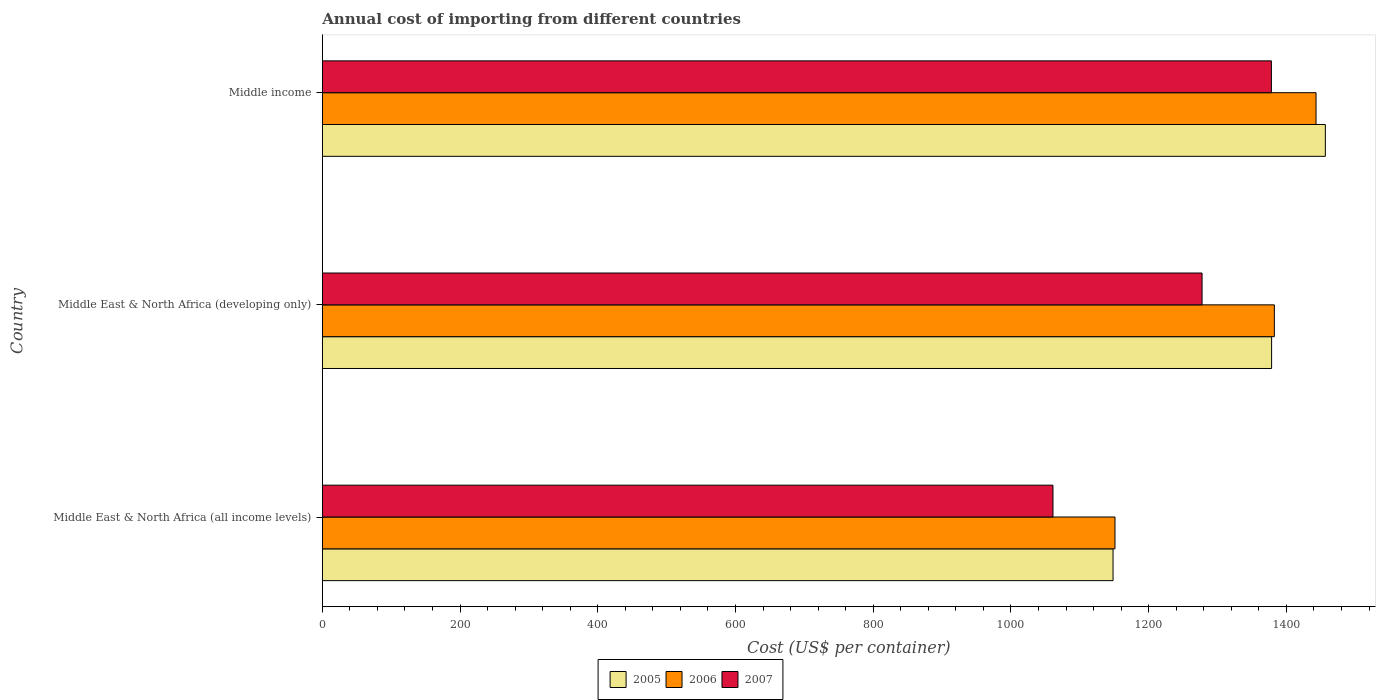How many different coloured bars are there?
Make the answer very short. 3. Are the number of bars per tick equal to the number of legend labels?
Offer a very short reply. Yes. How many bars are there on the 2nd tick from the bottom?
Give a very brief answer. 3. What is the label of the 2nd group of bars from the top?
Offer a terse response. Middle East & North Africa (developing only). In how many cases, is the number of bars for a given country not equal to the number of legend labels?
Offer a very short reply. 0. What is the total annual cost of importing in 2007 in Middle East & North Africa (all income levels)?
Ensure brevity in your answer.  1061. Across all countries, what is the maximum total annual cost of importing in 2007?
Provide a short and direct response. 1378.2. Across all countries, what is the minimum total annual cost of importing in 2005?
Your answer should be compact. 1148.24. In which country was the total annual cost of importing in 2006 minimum?
Give a very brief answer. Middle East & North Africa (all income levels). What is the total total annual cost of importing in 2005 in the graph?
Provide a succinct answer. 3983.27. What is the difference between the total annual cost of importing in 2006 in Middle East & North Africa (all income levels) and that in Middle East & North Africa (developing only)?
Ensure brevity in your answer.  -231.44. What is the difference between the total annual cost of importing in 2007 in Middle East & North Africa (developing only) and the total annual cost of importing in 2005 in Middle East & North Africa (all income levels)?
Your answer should be compact. 129.26. What is the average total annual cost of importing in 2005 per country?
Ensure brevity in your answer.  1327.76. What is the difference between the total annual cost of importing in 2006 and total annual cost of importing in 2005 in Middle East & North Africa (all income levels)?
Give a very brief answer. 2.82. In how many countries, is the total annual cost of importing in 2005 greater than 1320 US$?
Give a very brief answer. 2. What is the ratio of the total annual cost of importing in 2006 in Middle East & North Africa (all income levels) to that in Middle East & North Africa (developing only)?
Keep it short and to the point. 0.83. What is the difference between the highest and the second highest total annual cost of importing in 2006?
Provide a short and direct response. 60.51. What is the difference between the highest and the lowest total annual cost of importing in 2005?
Give a very brief answer. 308.3. In how many countries, is the total annual cost of importing in 2006 greater than the average total annual cost of importing in 2006 taken over all countries?
Your response must be concise. 2. What does the 3rd bar from the bottom in Middle income represents?
Make the answer very short. 2007. Is it the case that in every country, the sum of the total annual cost of importing in 2005 and total annual cost of importing in 2006 is greater than the total annual cost of importing in 2007?
Provide a short and direct response. Yes. Are all the bars in the graph horizontal?
Ensure brevity in your answer.  Yes. What is the difference between two consecutive major ticks on the X-axis?
Keep it short and to the point. 200. Are the values on the major ticks of X-axis written in scientific E-notation?
Your answer should be very brief. No. Does the graph contain grids?
Give a very brief answer. No. Where does the legend appear in the graph?
Provide a short and direct response. Bottom center. How many legend labels are there?
Your answer should be very brief. 3. How are the legend labels stacked?
Provide a succinct answer. Horizontal. What is the title of the graph?
Your answer should be compact. Annual cost of importing from different countries. What is the label or title of the X-axis?
Keep it short and to the point. Cost (US$ per container). What is the label or title of the Y-axis?
Provide a short and direct response. Country. What is the Cost (US$ per container) of 2005 in Middle East & North Africa (all income levels)?
Ensure brevity in your answer.  1148.24. What is the Cost (US$ per container) in 2006 in Middle East & North Africa (all income levels)?
Offer a very short reply. 1151.06. What is the Cost (US$ per container) of 2007 in Middle East & North Africa (all income levels)?
Offer a terse response. 1061. What is the Cost (US$ per container) of 2005 in Middle East & North Africa (developing only)?
Provide a short and direct response. 1378.5. What is the Cost (US$ per container) of 2006 in Middle East & North Africa (developing only)?
Your response must be concise. 1382.5. What is the Cost (US$ per container) in 2007 in Middle East & North Africa (developing only)?
Give a very brief answer. 1277.5. What is the Cost (US$ per container) in 2005 in Middle income?
Make the answer very short. 1456.53. What is the Cost (US$ per container) of 2006 in Middle income?
Keep it short and to the point. 1443.01. What is the Cost (US$ per container) in 2007 in Middle income?
Provide a short and direct response. 1378.2. Across all countries, what is the maximum Cost (US$ per container) in 2005?
Your answer should be very brief. 1456.53. Across all countries, what is the maximum Cost (US$ per container) in 2006?
Your answer should be very brief. 1443.01. Across all countries, what is the maximum Cost (US$ per container) of 2007?
Provide a short and direct response. 1378.2. Across all countries, what is the minimum Cost (US$ per container) of 2005?
Provide a succinct answer. 1148.24. Across all countries, what is the minimum Cost (US$ per container) of 2006?
Your answer should be very brief. 1151.06. Across all countries, what is the minimum Cost (US$ per container) in 2007?
Give a very brief answer. 1061. What is the total Cost (US$ per container) in 2005 in the graph?
Keep it short and to the point. 3983.27. What is the total Cost (US$ per container) of 2006 in the graph?
Provide a short and direct response. 3976.57. What is the total Cost (US$ per container) of 2007 in the graph?
Provide a short and direct response. 3716.7. What is the difference between the Cost (US$ per container) of 2005 in Middle East & North Africa (all income levels) and that in Middle East & North Africa (developing only)?
Provide a succinct answer. -230.26. What is the difference between the Cost (US$ per container) in 2006 in Middle East & North Africa (all income levels) and that in Middle East & North Africa (developing only)?
Your response must be concise. -231.44. What is the difference between the Cost (US$ per container) of 2007 in Middle East & North Africa (all income levels) and that in Middle East & North Africa (developing only)?
Make the answer very short. -216.5. What is the difference between the Cost (US$ per container) of 2005 in Middle East & North Africa (all income levels) and that in Middle income?
Make the answer very short. -308.3. What is the difference between the Cost (US$ per container) of 2006 in Middle East & North Africa (all income levels) and that in Middle income?
Offer a very short reply. -291.95. What is the difference between the Cost (US$ per container) of 2007 in Middle East & North Africa (all income levels) and that in Middle income?
Offer a very short reply. -317.2. What is the difference between the Cost (US$ per container) of 2005 in Middle East & North Africa (developing only) and that in Middle income?
Offer a terse response. -78.03. What is the difference between the Cost (US$ per container) of 2006 in Middle East & North Africa (developing only) and that in Middle income?
Your answer should be compact. -60.51. What is the difference between the Cost (US$ per container) of 2007 in Middle East & North Africa (developing only) and that in Middle income?
Make the answer very short. -100.7. What is the difference between the Cost (US$ per container) of 2005 in Middle East & North Africa (all income levels) and the Cost (US$ per container) of 2006 in Middle East & North Africa (developing only)?
Your answer should be very brief. -234.26. What is the difference between the Cost (US$ per container) in 2005 in Middle East & North Africa (all income levels) and the Cost (US$ per container) in 2007 in Middle East & North Africa (developing only)?
Offer a terse response. -129.26. What is the difference between the Cost (US$ per container) of 2006 in Middle East & North Africa (all income levels) and the Cost (US$ per container) of 2007 in Middle East & North Africa (developing only)?
Offer a terse response. -126.44. What is the difference between the Cost (US$ per container) in 2005 in Middle East & North Africa (all income levels) and the Cost (US$ per container) in 2006 in Middle income?
Ensure brevity in your answer.  -294.77. What is the difference between the Cost (US$ per container) in 2005 in Middle East & North Africa (all income levels) and the Cost (US$ per container) in 2007 in Middle income?
Your answer should be very brief. -229.96. What is the difference between the Cost (US$ per container) of 2006 in Middle East & North Africa (all income levels) and the Cost (US$ per container) of 2007 in Middle income?
Make the answer very short. -227.14. What is the difference between the Cost (US$ per container) of 2005 in Middle East & North Africa (developing only) and the Cost (US$ per container) of 2006 in Middle income?
Provide a short and direct response. -64.51. What is the difference between the Cost (US$ per container) of 2005 in Middle East & North Africa (developing only) and the Cost (US$ per container) of 2007 in Middle income?
Give a very brief answer. 0.3. What is the difference between the Cost (US$ per container) of 2006 in Middle East & North Africa (developing only) and the Cost (US$ per container) of 2007 in Middle income?
Keep it short and to the point. 4.3. What is the average Cost (US$ per container) in 2005 per country?
Your response must be concise. 1327.76. What is the average Cost (US$ per container) of 2006 per country?
Ensure brevity in your answer.  1325.52. What is the average Cost (US$ per container) in 2007 per country?
Your response must be concise. 1238.9. What is the difference between the Cost (US$ per container) of 2005 and Cost (US$ per container) of 2006 in Middle East & North Africa (all income levels)?
Give a very brief answer. -2.82. What is the difference between the Cost (US$ per container) of 2005 and Cost (US$ per container) of 2007 in Middle East & North Africa (all income levels)?
Keep it short and to the point. 87.24. What is the difference between the Cost (US$ per container) in 2006 and Cost (US$ per container) in 2007 in Middle East & North Africa (all income levels)?
Your response must be concise. 90.06. What is the difference between the Cost (US$ per container) in 2005 and Cost (US$ per container) in 2006 in Middle East & North Africa (developing only)?
Offer a very short reply. -4. What is the difference between the Cost (US$ per container) in 2005 and Cost (US$ per container) in 2007 in Middle East & North Africa (developing only)?
Your answer should be compact. 101. What is the difference between the Cost (US$ per container) of 2006 and Cost (US$ per container) of 2007 in Middle East & North Africa (developing only)?
Give a very brief answer. 105. What is the difference between the Cost (US$ per container) in 2005 and Cost (US$ per container) in 2006 in Middle income?
Make the answer very short. 13.52. What is the difference between the Cost (US$ per container) of 2005 and Cost (US$ per container) of 2007 in Middle income?
Keep it short and to the point. 78.34. What is the difference between the Cost (US$ per container) of 2006 and Cost (US$ per container) of 2007 in Middle income?
Make the answer very short. 64.81. What is the ratio of the Cost (US$ per container) in 2005 in Middle East & North Africa (all income levels) to that in Middle East & North Africa (developing only)?
Offer a terse response. 0.83. What is the ratio of the Cost (US$ per container) in 2006 in Middle East & North Africa (all income levels) to that in Middle East & North Africa (developing only)?
Your response must be concise. 0.83. What is the ratio of the Cost (US$ per container) of 2007 in Middle East & North Africa (all income levels) to that in Middle East & North Africa (developing only)?
Offer a terse response. 0.83. What is the ratio of the Cost (US$ per container) of 2005 in Middle East & North Africa (all income levels) to that in Middle income?
Provide a succinct answer. 0.79. What is the ratio of the Cost (US$ per container) in 2006 in Middle East & North Africa (all income levels) to that in Middle income?
Make the answer very short. 0.8. What is the ratio of the Cost (US$ per container) in 2007 in Middle East & North Africa (all income levels) to that in Middle income?
Keep it short and to the point. 0.77. What is the ratio of the Cost (US$ per container) in 2005 in Middle East & North Africa (developing only) to that in Middle income?
Make the answer very short. 0.95. What is the ratio of the Cost (US$ per container) in 2006 in Middle East & North Africa (developing only) to that in Middle income?
Offer a very short reply. 0.96. What is the ratio of the Cost (US$ per container) of 2007 in Middle East & North Africa (developing only) to that in Middle income?
Your answer should be compact. 0.93. What is the difference between the highest and the second highest Cost (US$ per container) in 2005?
Provide a short and direct response. 78.03. What is the difference between the highest and the second highest Cost (US$ per container) in 2006?
Your answer should be compact. 60.51. What is the difference between the highest and the second highest Cost (US$ per container) in 2007?
Offer a terse response. 100.7. What is the difference between the highest and the lowest Cost (US$ per container) of 2005?
Keep it short and to the point. 308.3. What is the difference between the highest and the lowest Cost (US$ per container) in 2006?
Offer a very short reply. 291.95. What is the difference between the highest and the lowest Cost (US$ per container) of 2007?
Your answer should be very brief. 317.2. 